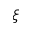Convert formula to latex. <formula><loc_0><loc_0><loc_500><loc_500>\xi</formula> 